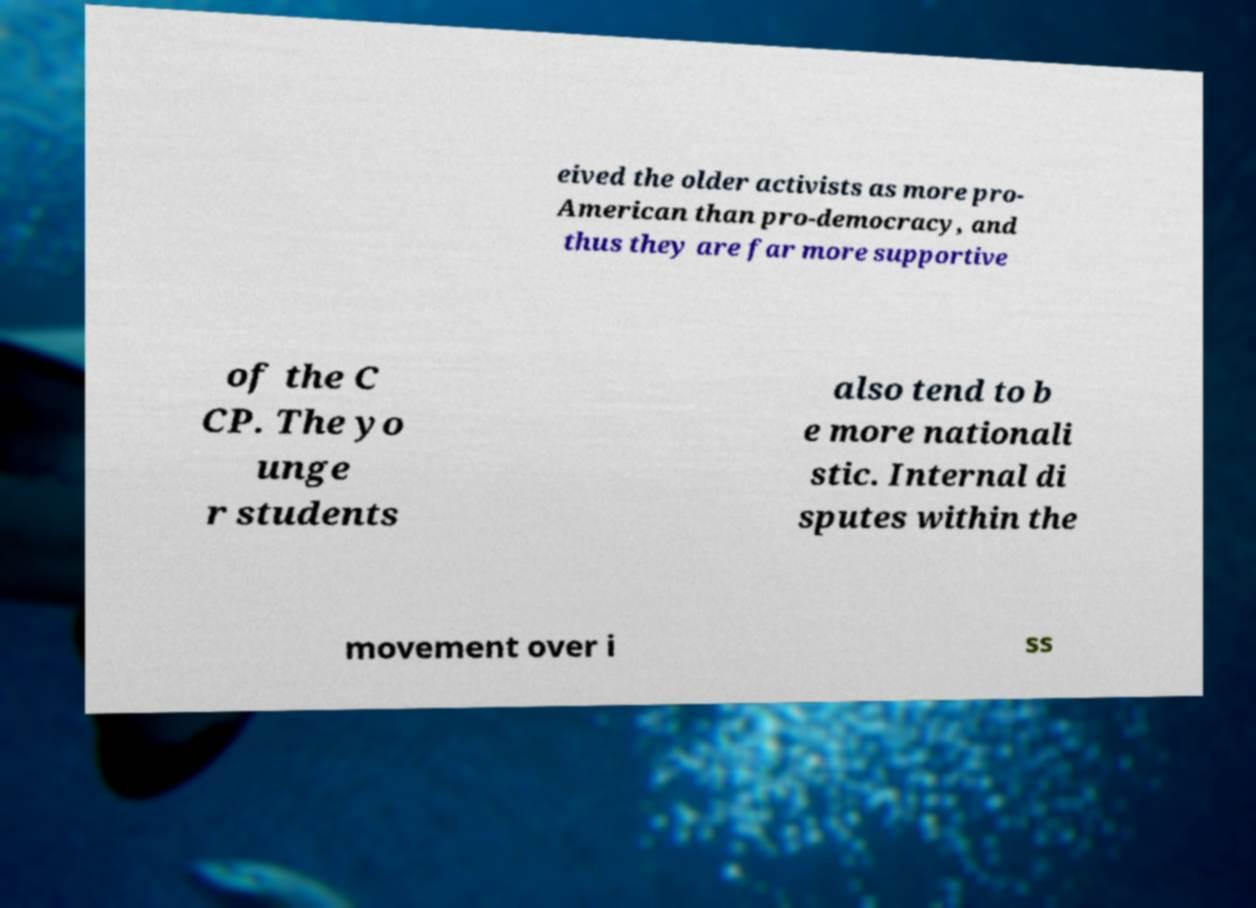For documentation purposes, I need the text within this image transcribed. Could you provide that? eived the older activists as more pro- American than pro-democracy, and thus they are far more supportive of the C CP. The yo unge r students also tend to b e more nationali stic. Internal di sputes within the movement over i ss 